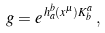Convert formula to latex. <formula><loc_0><loc_0><loc_500><loc_500>g = e ^ { \, h ^ { b } _ { a } ( x ^ { \mu } ) K ^ { a } _ { b } } \, ,</formula> 